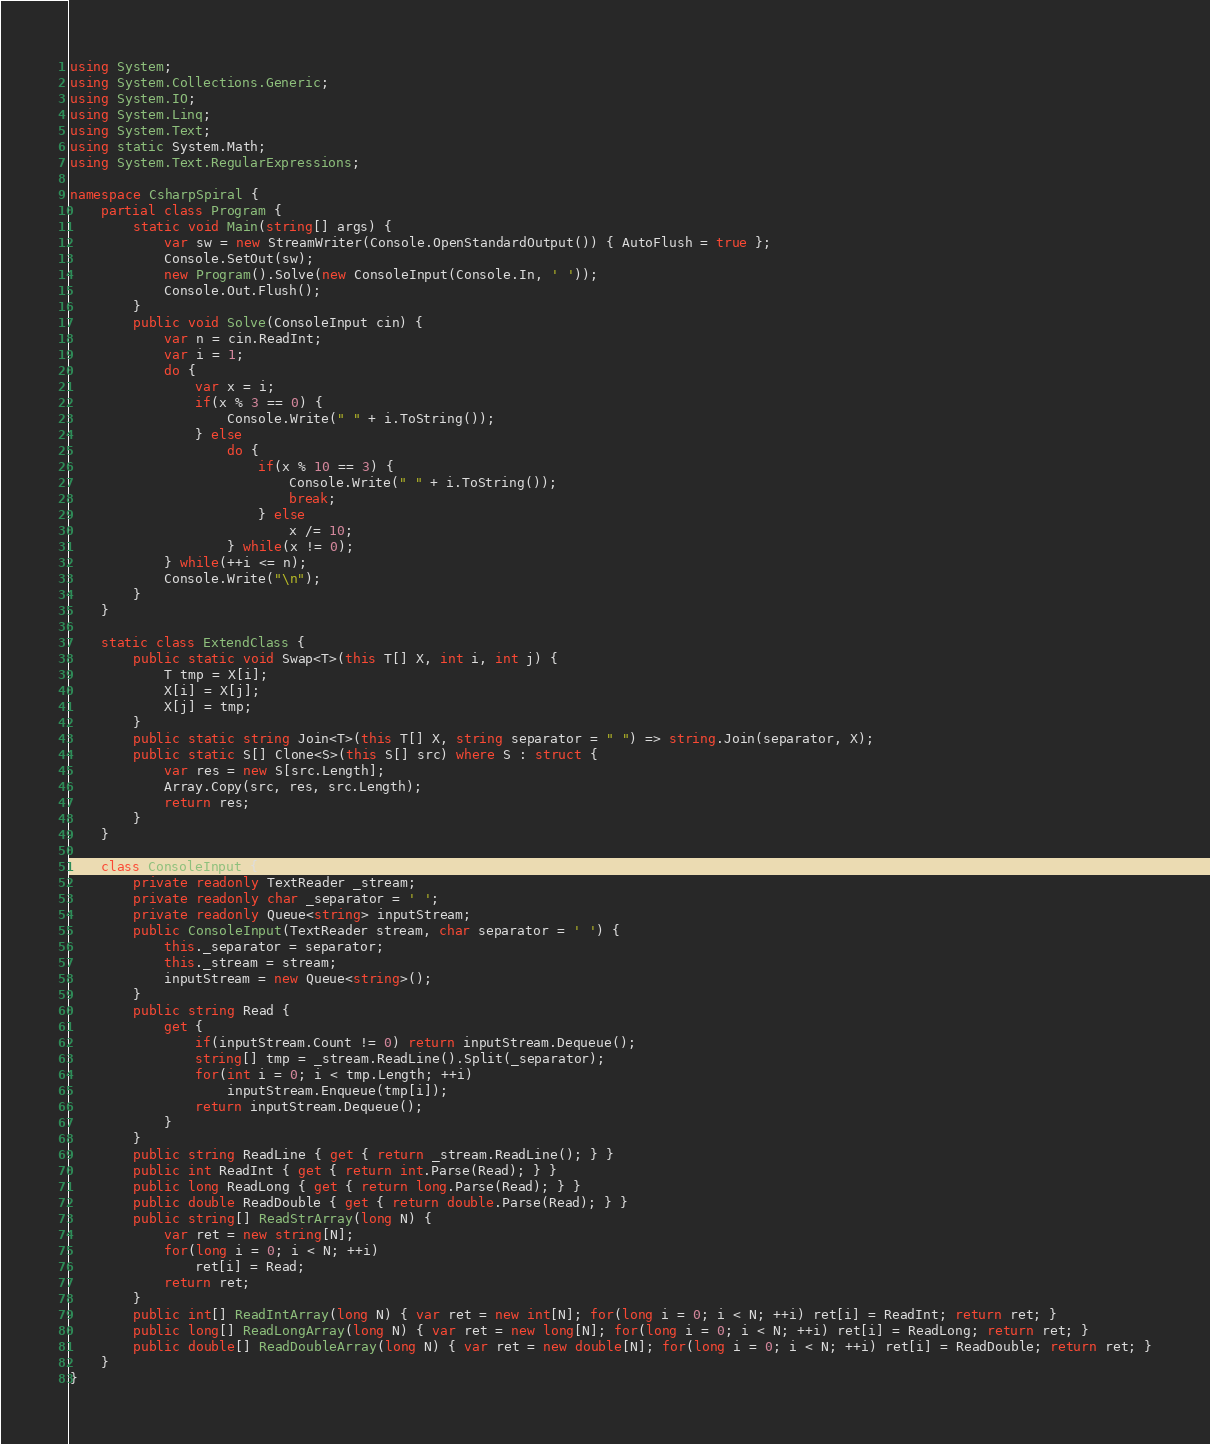<code> <loc_0><loc_0><loc_500><loc_500><_C#_>using System;
using System.Collections.Generic;
using System.IO;
using System.Linq;
using System.Text;
using static System.Math;
using System.Text.RegularExpressions;

namespace CsharpSpiral {
    partial class Program {
        static void Main(string[] args) {
            var sw = new StreamWriter(Console.OpenStandardOutput()) { AutoFlush = true };
            Console.SetOut(sw);
            new Program().Solve(new ConsoleInput(Console.In, ' '));
            Console.Out.Flush();
        }
        public void Solve(ConsoleInput cin) {
            var n = cin.ReadInt;
            var i = 1;
            do {
                var x = i;
                if(x % 3 == 0) {
                    Console.Write(" " + i.ToString());
                } else
                    do {
                        if(x % 10 == 3) {
                            Console.Write(" " + i.ToString());
                            break;
                        } else
                            x /= 10;
                    } while(x != 0);
            } while(++i <= n);
            Console.Write("\n");
        }
    }

    static class ExtendClass {
        public static void Swap<T>(this T[] X, int i, int j) {
            T tmp = X[i];
            X[i] = X[j];
            X[j] = tmp;
        }
        public static string Join<T>(this T[] X, string separator = " ") => string.Join(separator, X);
        public static S[] Clone<S>(this S[] src) where S : struct {
            var res = new S[src.Length];
            Array.Copy(src, res, src.Length);
            return res;
        }
    }

    class ConsoleInput {
        private readonly TextReader _stream;
        private readonly char _separator = ' ';
        private readonly Queue<string> inputStream;
        public ConsoleInput(TextReader stream, char separator = ' ') {
            this._separator = separator;
            this._stream = stream;
            inputStream = new Queue<string>();
        }
        public string Read {
            get {
                if(inputStream.Count != 0) return inputStream.Dequeue();
                string[] tmp = _stream.ReadLine().Split(_separator);
                for(int i = 0; i < tmp.Length; ++i)
                    inputStream.Enqueue(tmp[i]);
                return inputStream.Dequeue();
            }
        }
        public string ReadLine { get { return _stream.ReadLine(); } }
        public int ReadInt { get { return int.Parse(Read); } }
        public long ReadLong { get { return long.Parse(Read); } }
        public double ReadDouble { get { return double.Parse(Read); } }
        public string[] ReadStrArray(long N) {
            var ret = new string[N];
            for(long i = 0; i < N; ++i)
                ret[i] = Read;
            return ret;
        }
        public int[] ReadIntArray(long N) { var ret = new int[N]; for(long i = 0; i < N; ++i) ret[i] = ReadInt; return ret; }
        public long[] ReadLongArray(long N) { var ret = new long[N]; for(long i = 0; i < N; ++i) ret[i] = ReadLong; return ret; }
        public double[] ReadDoubleArray(long N) { var ret = new double[N]; for(long i = 0; i < N; ++i) ret[i] = ReadDouble; return ret; }
    }
}

</code> 